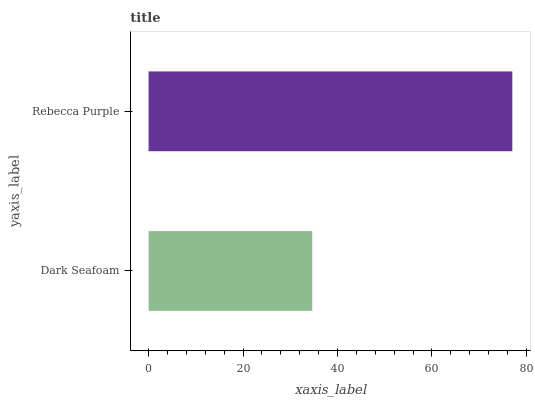Is Dark Seafoam the minimum?
Answer yes or no. Yes. Is Rebecca Purple the maximum?
Answer yes or no. Yes. Is Rebecca Purple the minimum?
Answer yes or no. No. Is Rebecca Purple greater than Dark Seafoam?
Answer yes or no. Yes. Is Dark Seafoam less than Rebecca Purple?
Answer yes or no. Yes. Is Dark Seafoam greater than Rebecca Purple?
Answer yes or no. No. Is Rebecca Purple less than Dark Seafoam?
Answer yes or no. No. Is Rebecca Purple the high median?
Answer yes or no. Yes. Is Dark Seafoam the low median?
Answer yes or no. Yes. Is Dark Seafoam the high median?
Answer yes or no. No. Is Rebecca Purple the low median?
Answer yes or no. No. 